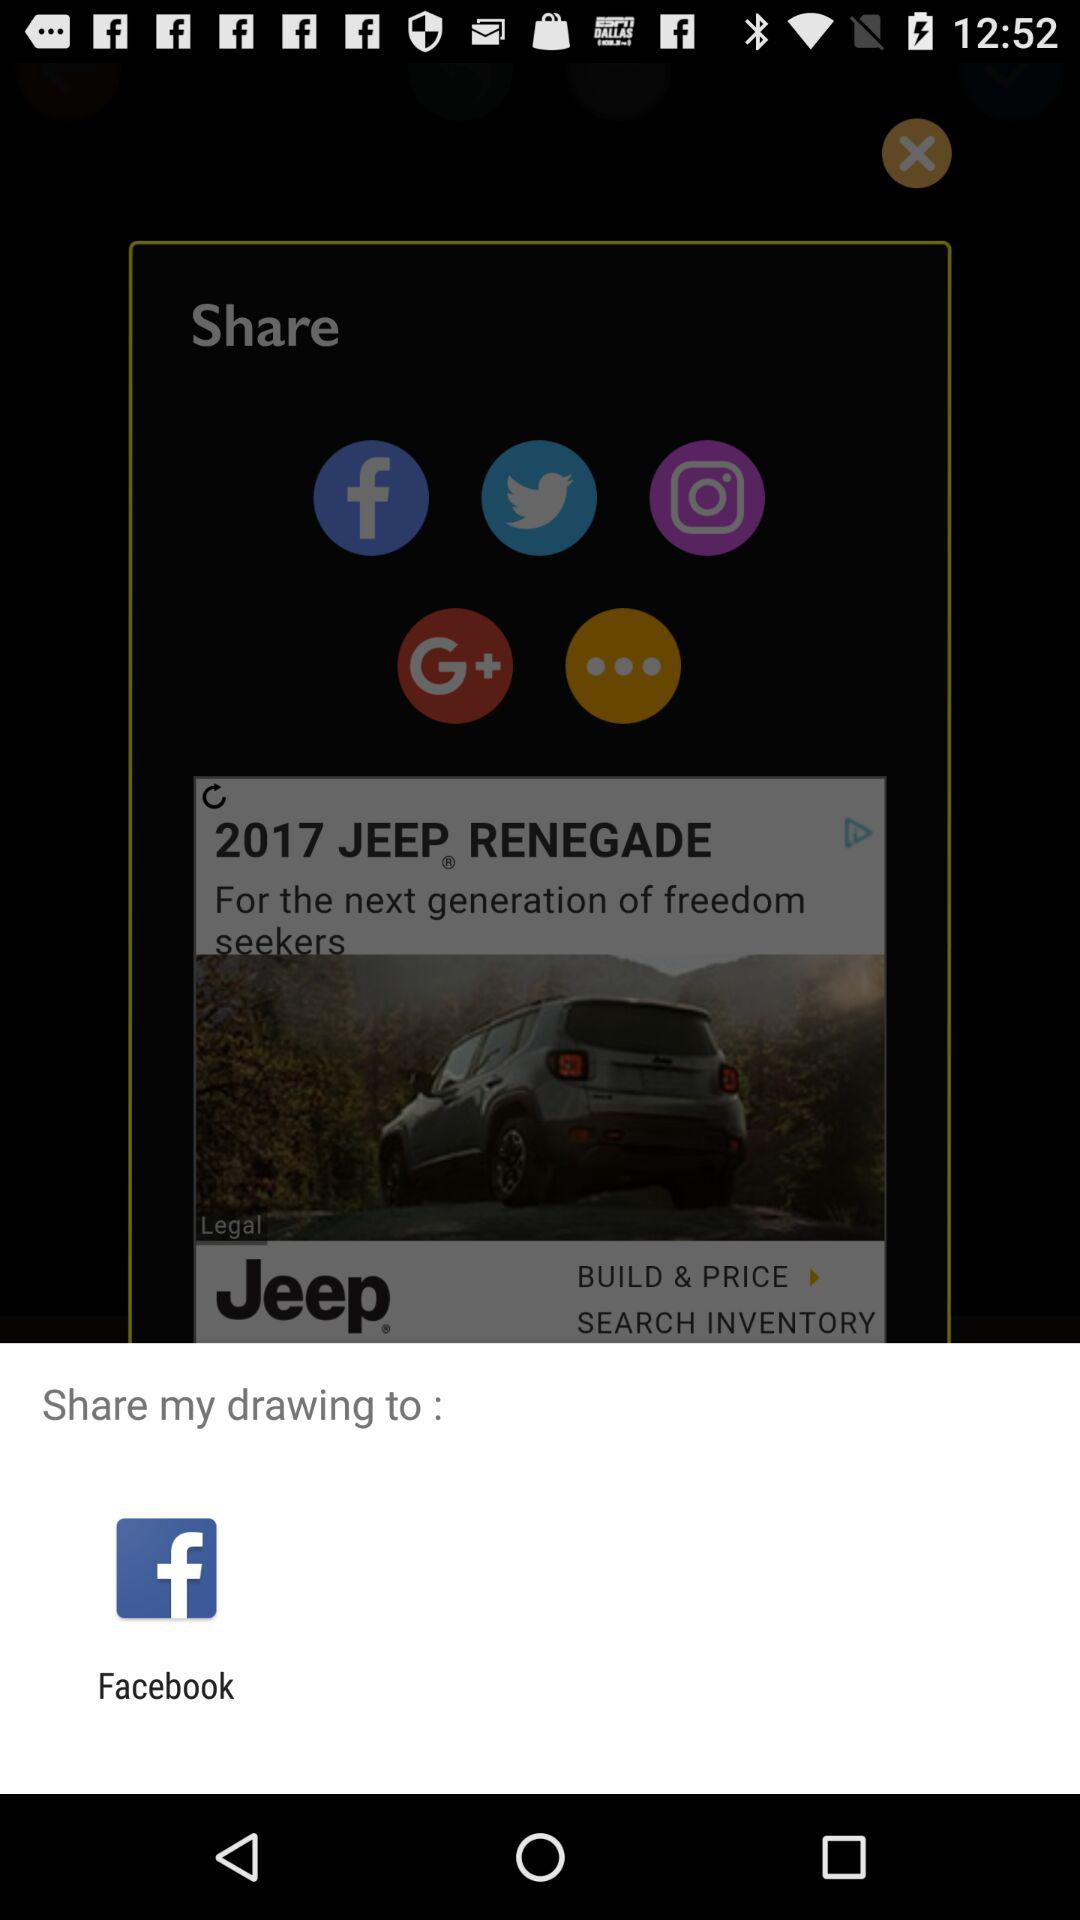Who is sharing the content?
When the provided information is insufficient, respond with <no answer>. <no answer> 